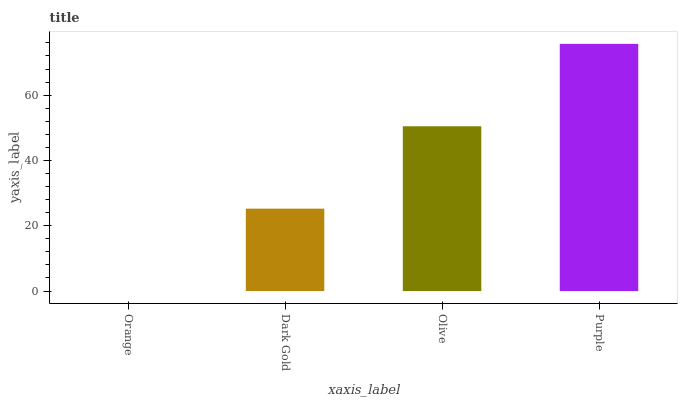Is Orange the minimum?
Answer yes or no. Yes. Is Purple the maximum?
Answer yes or no. Yes. Is Dark Gold the minimum?
Answer yes or no. No. Is Dark Gold the maximum?
Answer yes or no. No. Is Dark Gold greater than Orange?
Answer yes or no. Yes. Is Orange less than Dark Gold?
Answer yes or no. Yes. Is Orange greater than Dark Gold?
Answer yes or no. No. Is Dark Gold less than Orange?
Answer yes or no. No. Is Olive the high median?
Answer yes or no. Yes. Is Dark Gold the low median?
Answer yes or no. Yes. Is Dark Gold the high median?
Answer yes or no. No. Is Purple the low median?
Answer yes or no. No. 